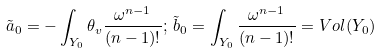<formula> <loc_0><loc_0><loc_500><loc_500>\tilde { a } _ { 0 } = - \int _ { Y _ { 0 } } \theta _ { v } \frac { { \omega } ^ { n - 1 } } { ( n - 1 ) ! } ; \, \tilde { b } _ { 0 } = \int _ { Y _ { 0 } } \frac { { \omega } ^ { n - 1 } } { ( n - 1 ) ! } = V o l ( Y _ { 0 } )</formula> 